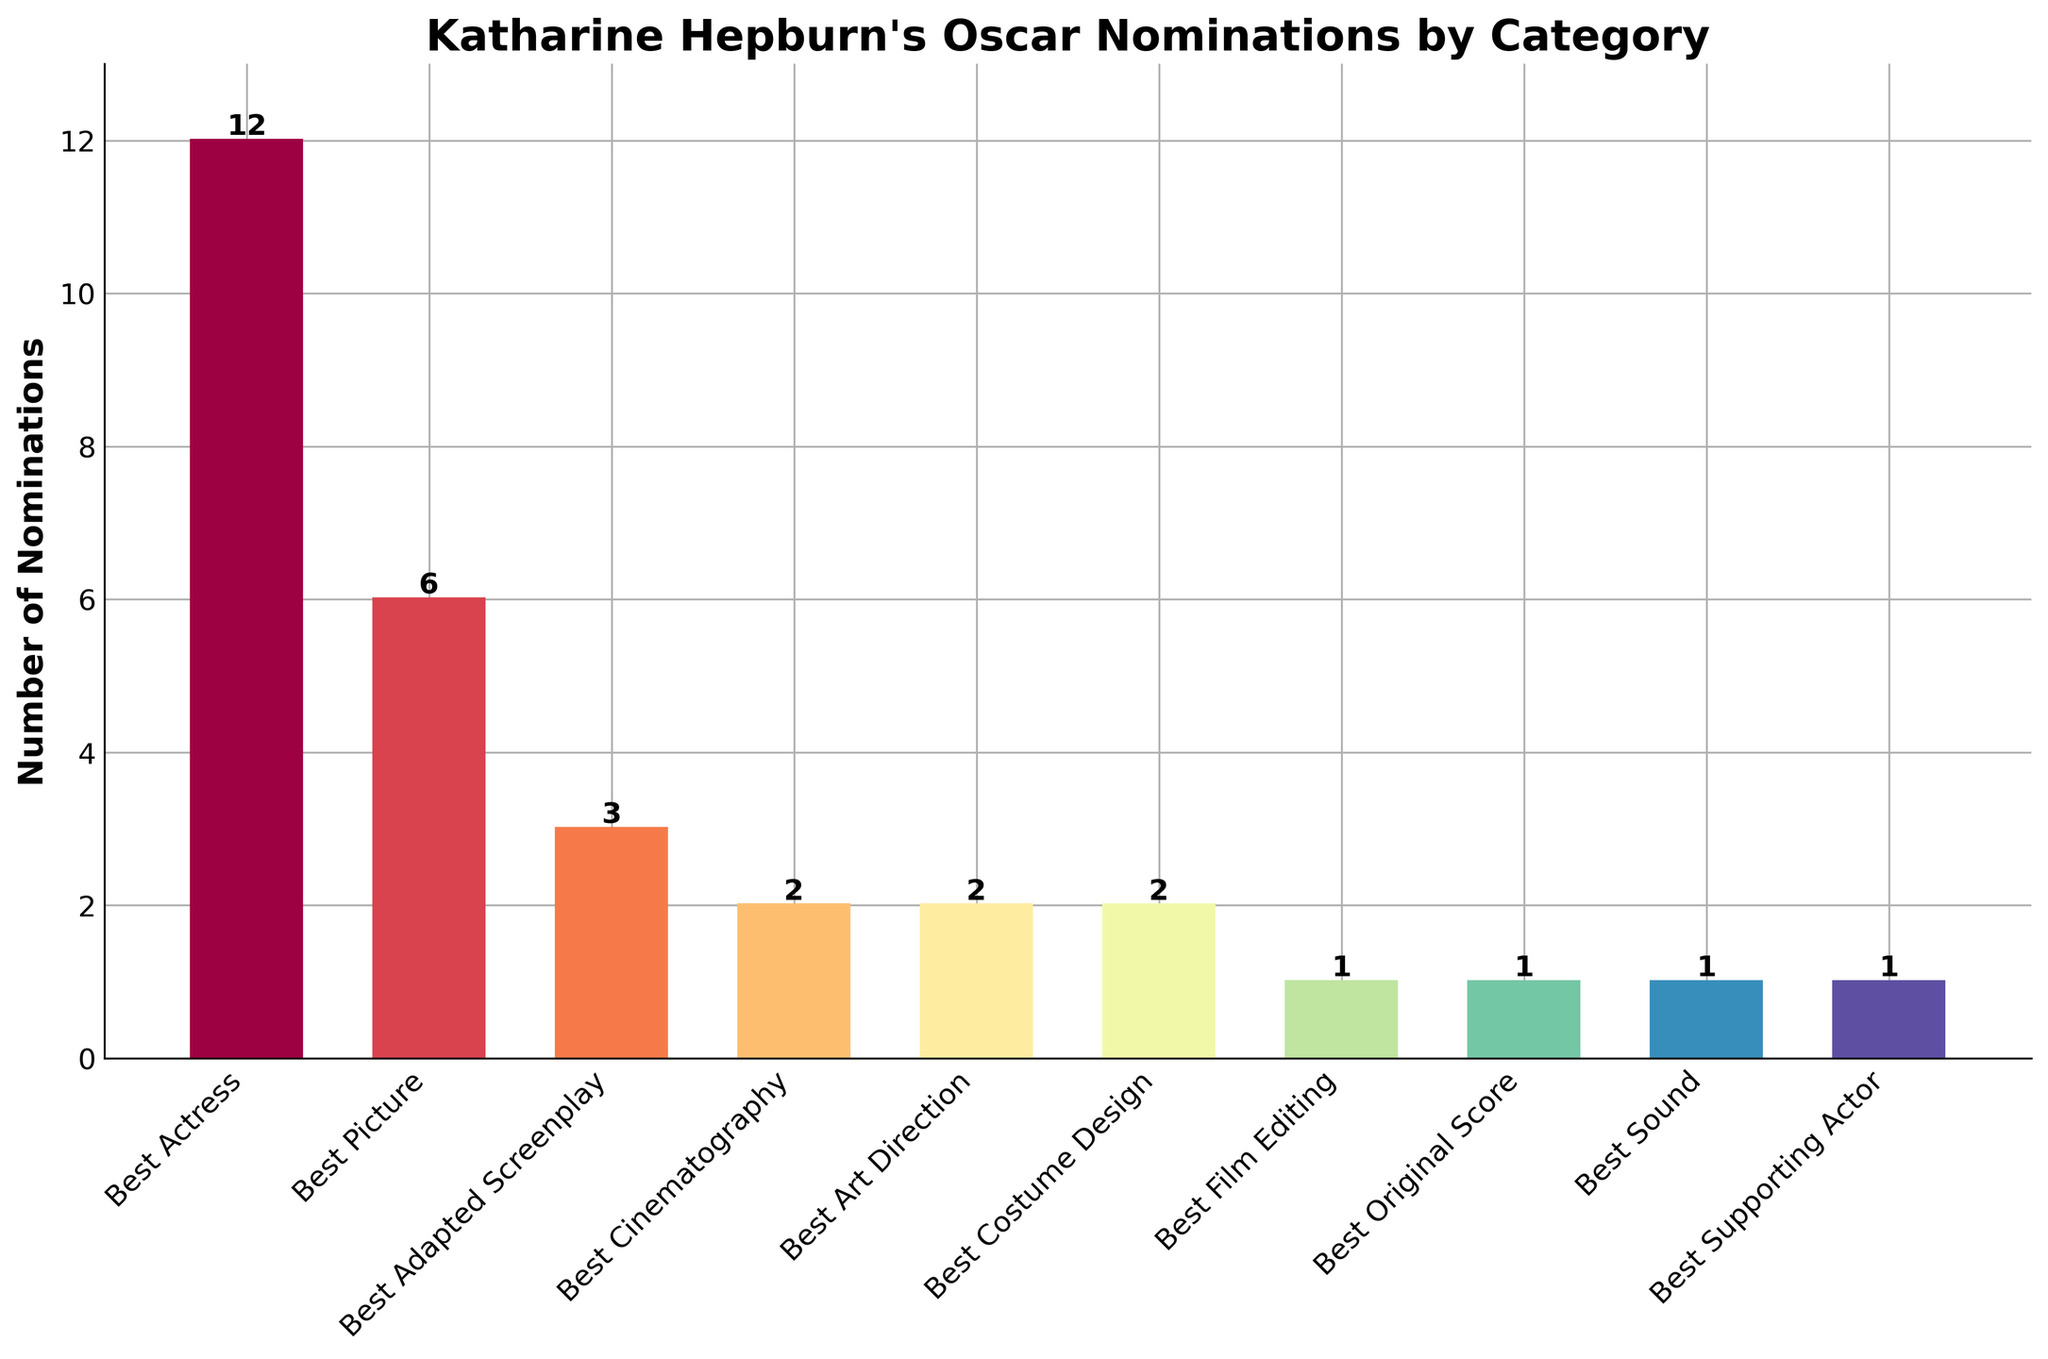What category has the most Oscar nominations for Katharine Hepburn's films? The bar for "Best Actress" is the tallest among all the bars
Answer: Best Actress By how many nominations does "Best Actress" lead over the next highest category? The "Best Actress" category has 12 nominations, while the next highest, "Best Picture," has 6 nominations. The difference is 12 - 6 = 6
Answer: 6 Which categories have the same number of nominations and what is that number? Best Cinematography, Best Art Direction, and Best Costume Design each have 2 nominations, and Best Film Editing, Best Original Score, Best Sound, and Best Supporting Actor each have 1 nomination
Answer: 2, 1 How many total Oscar nominations do Katharine Hepburn's films have across all categories? Sum the number of nominations for all categories: 12 (Best Actress) + 6 (Best Picture) + 3 (Best Adapted Screenplay) + 2 (Best Cinematography) + 2 (Best Art Direction) + 2 (Best Costume Design) + 1 (Best Film Editing) + 1 (Best Original Score) + 1 (Best Sound) + 1 (Best Supporting Actor) = 31
Answer: 31 How many categories have more than 2 nominations? The categories that have more than 2 nominations are: Best Actress (12), Best Picture (6), Best Adapted Screenplay (3)
Answer: 3 Compare the number of nominations for "Best Picture" and "Best Adapted Screenplay". How many more nominations does "Best Picture" have? The "Best Picture" category has 6 nominations, while "Best Adapted Screenplay" has 3 nominations. The difference is 6 - 3 = 3
Answer: 3 Calculate the average number of nominations per category. Sum the total number of nominations (31) and divide by the number of categories (10): 31 / 10 = 3.1
Answer: 3.1 In terms of nominations, which categories are equally represented? Categories with equal nominations are Best Cinematography, Best Art Direction, and Best Costume Design (each with 2 nominations), and Best Film Editing, Best Original Score, Best Sound, and Best Supporting Actor (each with 1 nomination)
Answer: Best Cinematography, Best Art Direction, Best Costume Design (2 nominations), Best Film Editing, Best Original Score, Best Sound, Best Supporting Actor (1 nomination) Is there any category with only one nomination? If yes, name them. Yes, the categories Best Film Editing, Best Original Score, Best Sound, and Best Supporting Actor each have only one nomination
Answer: Best Film Editing, Best Original Score, Best Sound, Best Supporting Actor 